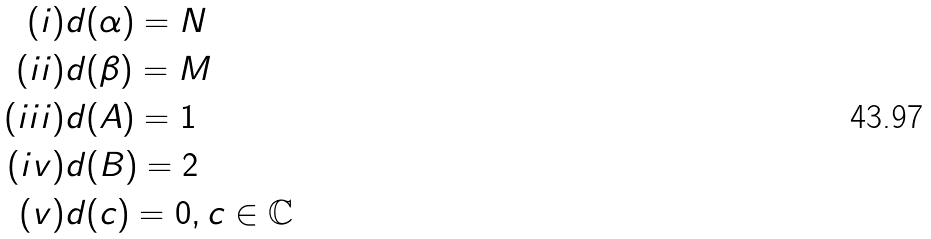<formula> <loc_0><loc_0><loc_500><loc_500>( i ) & d ( \alpha ) = N \\ ( i i ) & d ( \beta ) = M \\ ( i i i ) & d ( A ) = 1 \\ ( i v ) & d ( B ) = 2 \\ ( v ) & d ( c ) = 0 , c \in \mathbb { C } \\</formula> 